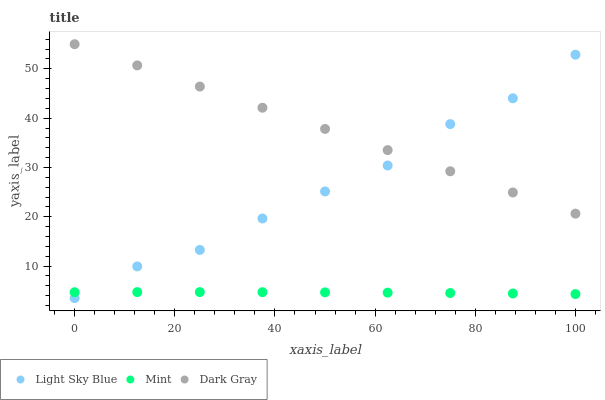Does Mint have the minimum area under the curve?
Answer yes or no. Yes. Does Dark Gray have the maximum area under the curve?
Answer yes or no. Yes. Does Light Sky Blue have the minimum area under the curve?
Answer yes or no. No. Does Light Sky Blue have the maximum area under the curve?
Answer yes or no. No. Is Dark Gray the smoothest?
Answer yes or no. Yes. Is Light Sky Blue the roughest?
Answer yes or no. Yes. Is Mint the smoothest?
Answer yes or no. No. Is Mint the roughest?
Answer yes or no. No. Does Light Sky Blue have the lowest value?
Answer yes or no. Yes. Does Mint have the lowest value?
Answer yes or no. No. Does Dark Gray have the highest value?
Answer yes or no. Yes. Does Light Sky Blue have the highest value?
Answer yes or no. No. Is Mint less than Dark Gray?
Answer yes or no. Yes. Is Dark Gray greater than Mint?
Answer yes or no. Yes. Does Light Sky Blue intersect Mint?
Answer yes or no. Yes. Is Light Sky Blue less than Mint?
Answer yes or no. No. Is Light Sky Blue greater than Mint?
Answer yes or no. No. Does Mint intersect Dark Gray?
Answer yes or no. No. 